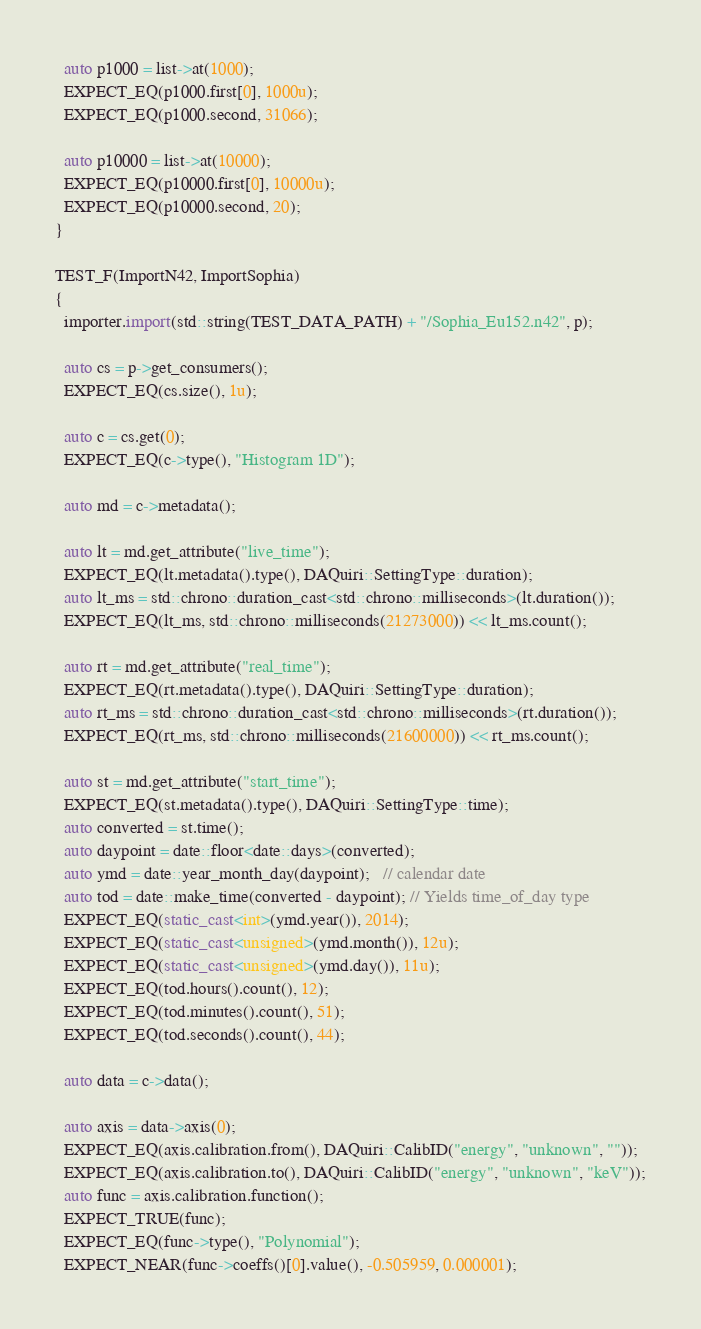Convert code to text. <code><loc_0><loc_0><loc_500><loc_500><_C++_>  auto p1000 = list->at(1000);
  EXPECT_EQ(p1000.first[0], 1000u);
  EXPECT_EQ(p1000.second, 31066);

  auto p10000 = list->at(10000);
  EXPECT_EQ(p10000.first[0], 10000u);
  EXPECT_EQ(p10000.second, 20);
}

TEST_F(ImportN42, ImportSophia)
{
  importer.import(std::string(TEST_DATA_PATH) + "/Sophia_Eu152.n42", p);

  auto cs = p->get_consumers();
  EXPECT_EQ(cs.size(), 1u);

  auto c = cs.get(0);
  EXPECT_EQ(c->type(), "Histogram 1D");

  auto md = c->metadata();

  auto lt = md.get_attribute("live_time");
  EXPECT_EQ(lt.metadata().type(), DAQuiri::SettingType::duration);
  auto lt_ms = std::chrono::duration_cast<std::chrono::milliseconds>(lt.duration());
  EXPECT_EQ(lt_ms, std::chrono::milliseconds(21273000)) << lt_ms.count();

  auto rt = md.get_attribute("real_time");
  EXPECT_EQ(rt.metadata().type(), DAQuiri::SettingType::duration);
  auto rt_ms = std::chrono::duration_cast<std::chrono::milliseconds>(rt.duration());
  EXPECT_EQ(rt_ms, std::chrono::milliseconds(21600000)) << rt_ms.count();

  auto st = md.get_attribute("start_time");
  EXPECT_EQ(st.metadata().type(), DAQuiri::SettingType::time);
  auto converted = st.time();
  auto daypoint = date::floor<date::days>(converted);
  auto ymd = date::year_month_day(daypoint);   // calendar date
  auto tod = date::make_time(converted - daypoint); // Yields time_of_day type
  EXPECT_EQ(static_cast<int>(ymd.year()), 2014);
  EXPECT_EQ(static_cast<unsigned>(ymd.month()), 12u);
  EXPECT_EQ(static_cast<unsigned>(ymd.day()), 11u);
  EXPECT_EQ(tod.hours().count(), 12);
  EXPECT_EQ(tod.minutes().count(), 51);
  EXPECT_EQ(tod.seconds().count(), 44);

  auto data = c->data();

  auto axis = data->axis(0);
  EXPECT_EQ(axis.calibration.from(), DAQuiri::CalibID("energy", "unknown", ""));
  EXPECT_EQ(axis.calibration.to(), DAQuiri::CalibID("energy", "unknown", "keV"));
  auto func = axis.calibration.function();
  EXPECT_TRUE(func);
  EXPECT_EQ(func->type(), "Polynomial");
  EXPECT_NEAR(func->coeffs()[0].value(), -0.505959, 0.000001);</code> 